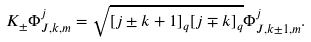<formula> <loc_0><loc_0><loc_500><loc_500>K _ { \pm } \Phi _ { J , k , m } ^ { j } = \sqrt { [ j \pm k + 1 ] _ { q } [ j \mp k ] _ { q } } \Phi _ { J , k \pm 1 , m } ^ { j } .</formula> 